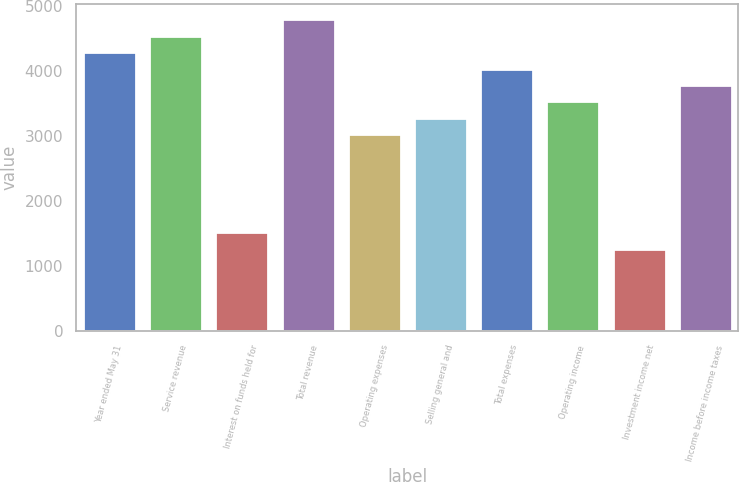Convert chart to OTSL. <chart><loc_0><loc_0><loc_500><loc_500><bar_chart><fcel>Year ended May 31<fcel>Service revenue<fcel>Interest on funds held for<fcel>Total revenue<fcel>Operating expenses<fcel>Selling general and<fcel>Total expenses<fcel>Operating income<fcel>Investment income net<fcel>Income before income taxes<nl><fcel>4281.78<fcel>4533.62<fcel>1511.54<fcel>4785.46<fcel>3022.58<fcel>3274.42<fcel>4029.94<fcel>3526.26<fcel>1259.7<fcel>3778.1<nl></chart> 